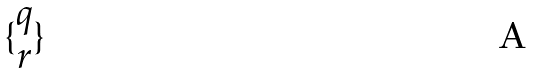Convert formula to latex. <formula><loc_0><loc_0><loc_500><loc_500>\{ \begin{matrix} q \\ r \end{matrix} \}</formula> 